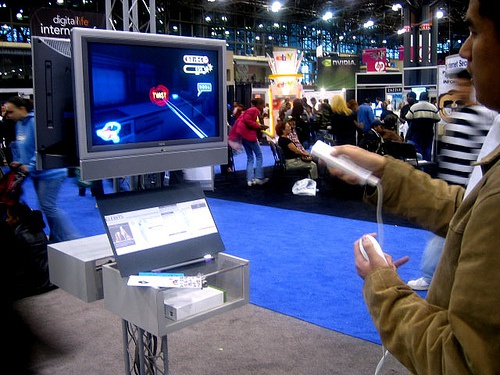Describe the objects in this image and their specific colors. I can see people in black, olive, and gray tones, tv in black, navy, gray, and darkblue tones, tv in black, navy, and gray tones, people in black, darkgray, lavender, and gray tones, and people in black, navy, white, and gray tones in this image. 